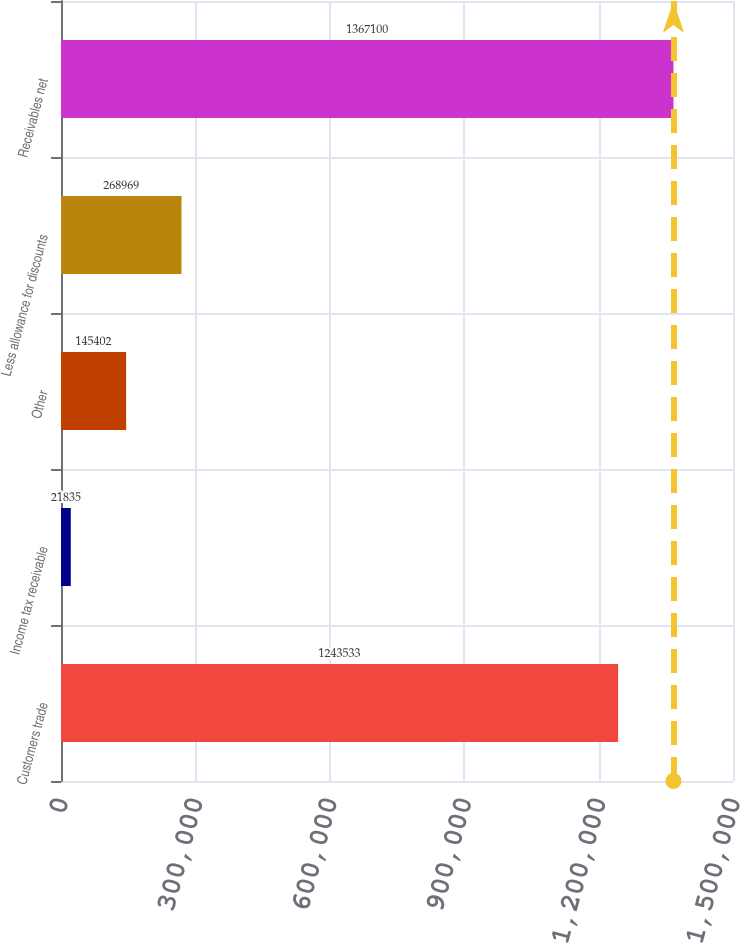Convert chart to OTSL. <chart><loc_0><loc_0><loc_500><loc_500><bar_chart><fcel>Customers trade<fcel>Income tax receivable<fcel>Other<fcel>Less allowance for discounts<fcel>Receivables net<nl><fcel>1.24353e+06<fcel>21835<fcel>145402<fcel>268969<fcel>1.3671e+06<nl></chart> 